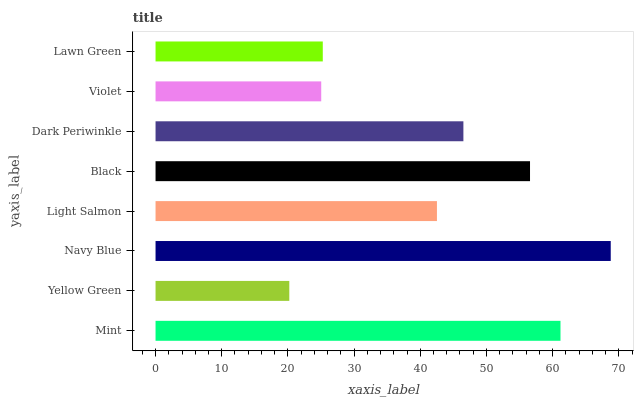Is Yellow Green the minimum?
Answer yes or no. Yes. Is Navy Blue the maximum?
Answer yes or no. Yes. Is Navy Blue the minimum?
Answer yes or no. No. Is Yellow Green the maximum?
Answer yes or no. No. Is Navy Blue greater than Yellow Green?
Answer yes or no. Yes. Is Yellow Green less than Navy Blue?
Answer yes or no. Yes. Is Yellow Green greater than Navy Blue?
Answer yes or no. No. Is Navy Blue less than Yellow Green?
Answer yes or no. No. Is Dark Periwinkle the high median?
Answer yes or no. Yes. Is Light Salmon the low median?
Answer yes or no. Yes. Is Light Salmon the high median?
Answer yes or no. No. Is Yellow Green the low median?
Answer yes or no. No. 